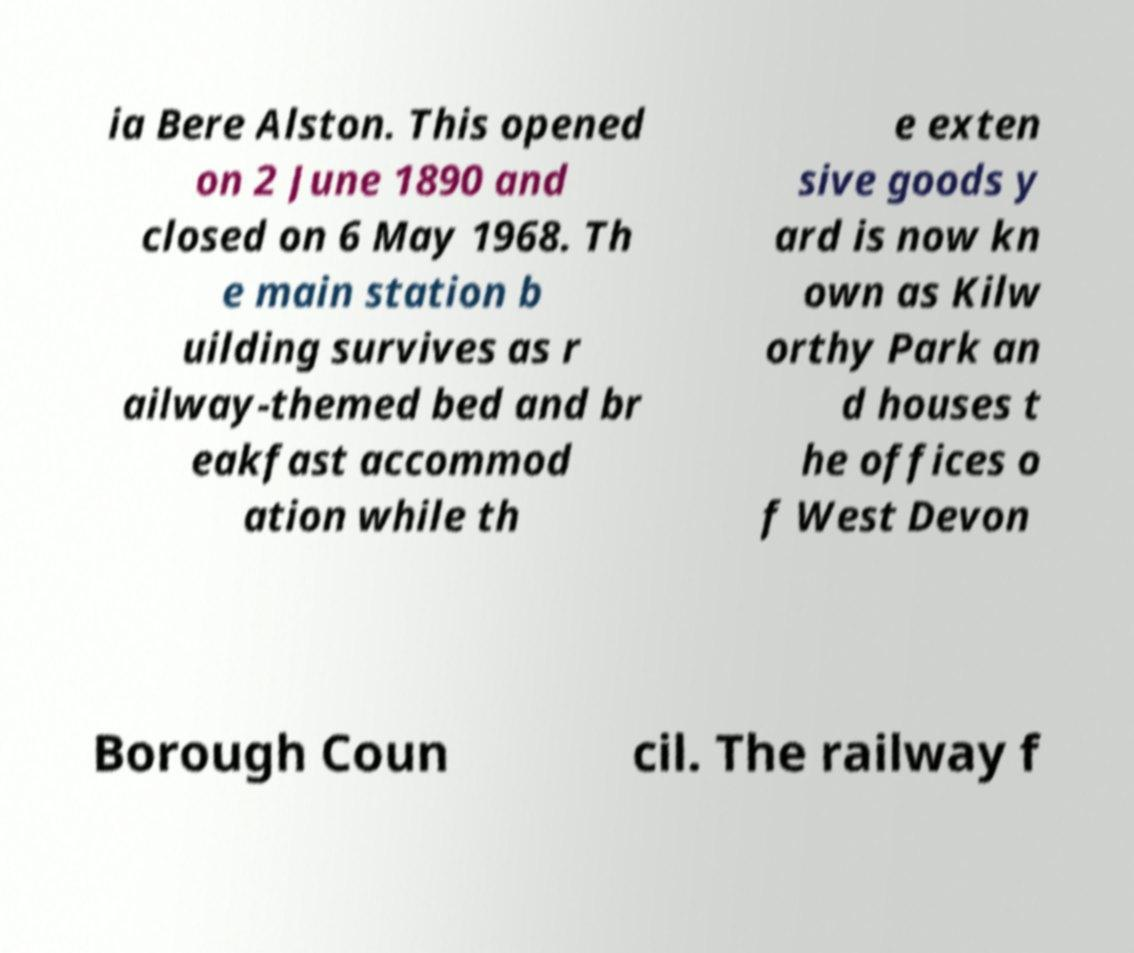What messages or text are displayed in this image? I need them in a readable, typed format. ia Bere Alston. This opened on 2 June 1890 and closed on 6 May 1968. Th e main station b uilding survives as r ailway-themed bed and br eakfast accommod ation while th e exten sive goods y ard is now kn own as Kilw orthy Park an d houses t he offices o f West Devon Borough Coun cil. The railway f 